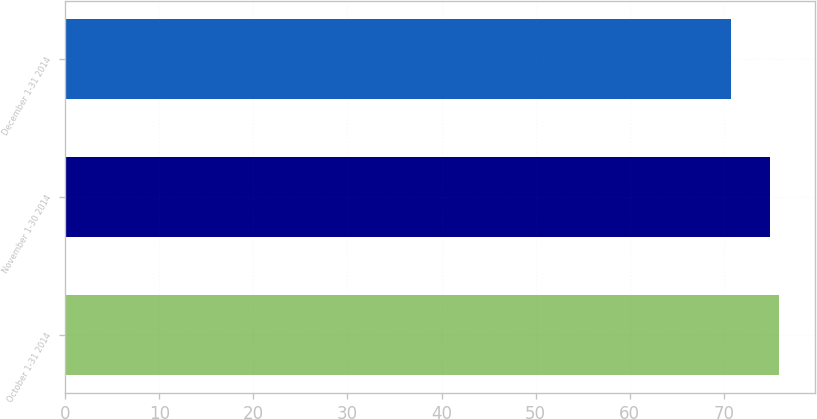<chart> <loc_0><loc_0><loc_500><loc_500><bar_chart><fcel>October 1-31 2014<fcel>November 1-30 2014<fcel>December 1-31 2014<nl><fcel>75.86<fcel>74.97<fcel>70.81<nl></chart> 